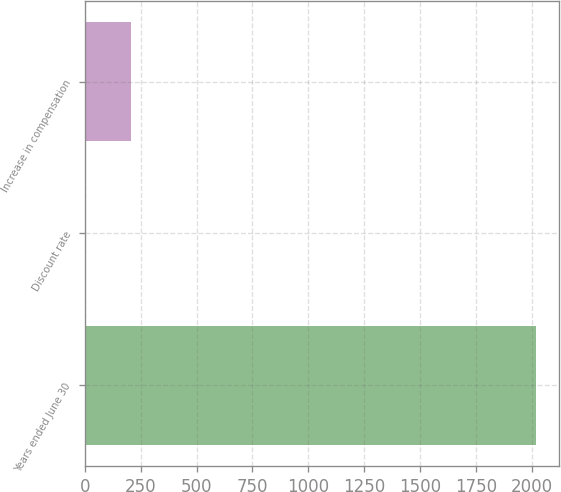Convert chart. <chart><loc_0><loc_0><loc_500><loc_500><bar_chart><fcel>Years ended June 30<fcel>Discount rate<fcel>Increase in compensation<nl><fcel>2019<fcel>3.4<fcel>204.96<nl></chart> 